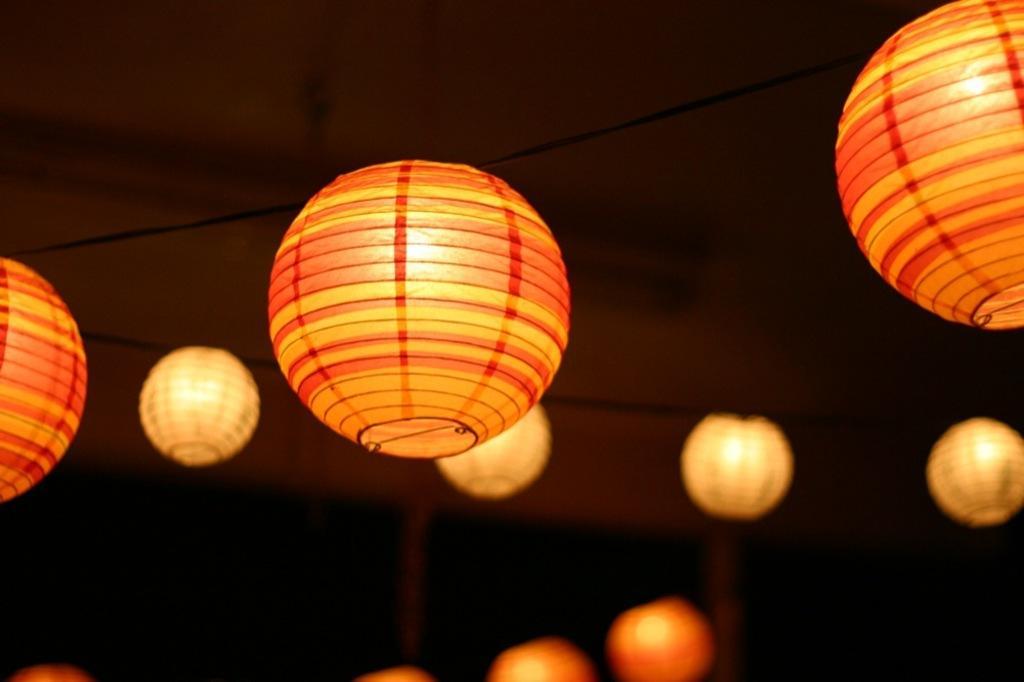Could you give a brief overview of what you see in this image? This image consists of many lights hanged to the roof. It looks like balls. To the top, there is roof. The room looks too dark. 